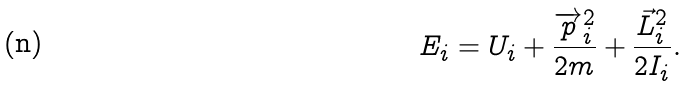Convert formula to latex. <formula><loc_0><loc_0><loc_500><loc_500>E _ { i } = U _ { i } + \frac { \overrightarrow { p } _ { i } ^ { 2 } } { 2 m } + \frac { \vec { L } _ { i } ^ { 2 } } { 2 I _ { i } } .</formula> 